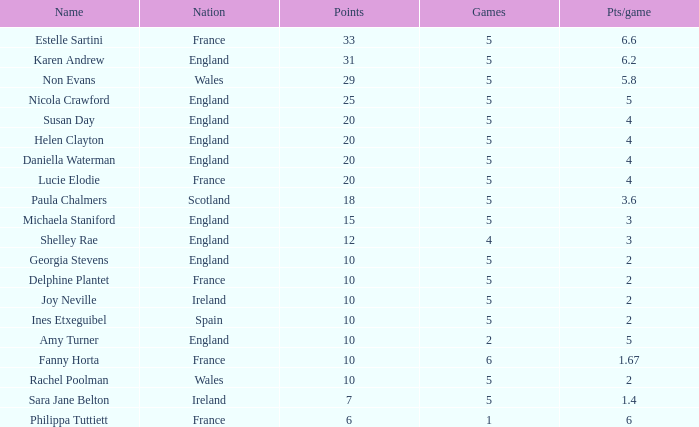4 and a points score of 20, along with susan day's name? 5.0. 